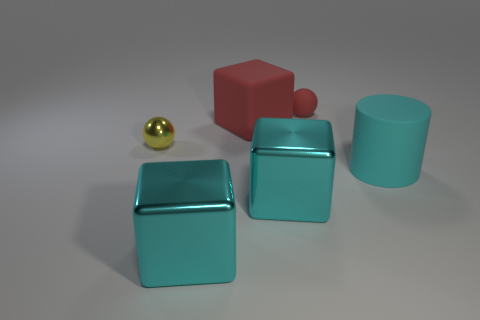Add 2 big purple matte things. How many objects exist? 8 Subtract all cylinders. How many objects are left? 5 Subtract 0 blue cylinders. How many objects are left? 6 Subtract all cyan matte things. Subtract all big shiny objects. How many objects are left? 3 Add 3 red matte cubes. How many red matte cubes are left? 4 Add 3 big metal things. How many big metal things exist? 5 